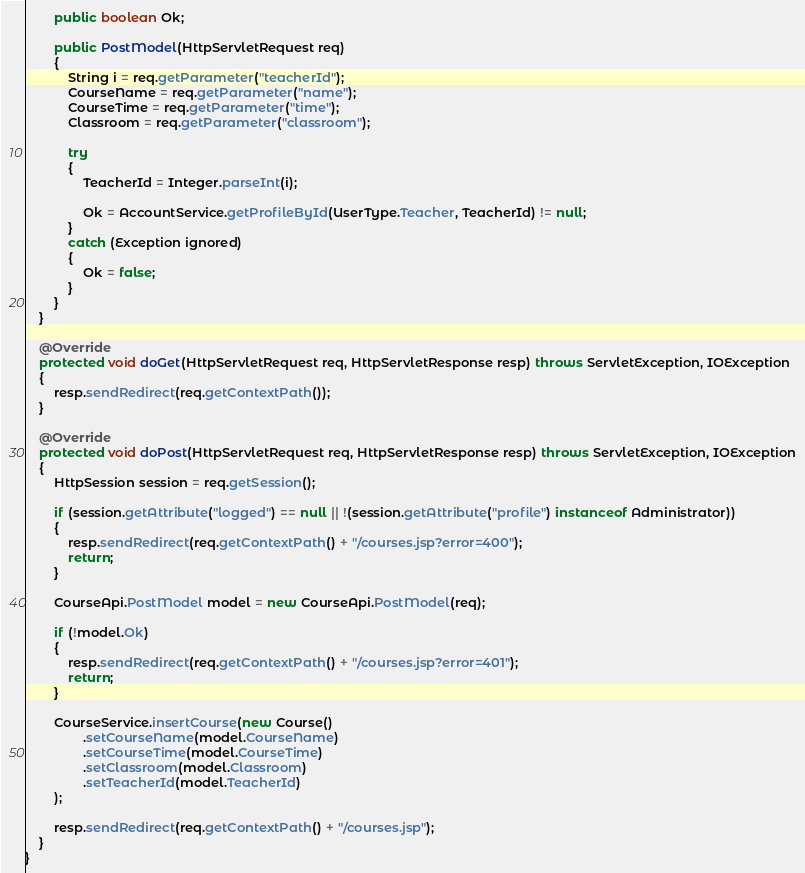Convert code to text. <code><loc_0><loc_0><loc_500><loc_500><_Java_>
        public boolean Ok;

        public PostModel(HttpServletRequest req)
        {
            String i = req.getParameter("teacherId");
            CourseName = req.getParameter("name");
            CourseTime = req.getParameter("time");
            Classroom = req.getParameter("classroom");

            try
            {
                TeacherId = Integer.parseInt(i);

                Ok = AccountService.getProfileById(UserType.Teacher, TeacherId) != null;
            }
            catch (Exception ignored)
            {
                Ok = false;
            }
        }
    }

    @Override
    protected void doGet(HttpServletRequest req, HttpServletResponse resp) throws ServletException, IOException
    {
        resp.sendRedirect(req.getContextPath());
    }

    @Override
    protected void doPost(HttpServletRequest req, HttpServletResponse resp) throws ServletException, IOException
    {
        HttpSession session = req.getSession();

        if (session.getAttribute("logged") == null || !(session.getAttribute("profile") instanceof Administrator))
        {
            resp.sendRedirect(req.getContextPath() + "/courses.jsp?error=400");
            return;
        }

        CourseApi.PostModel model = new CourseApi.PostModel(req);

        if (!model.Ok)
        {
            resp.sendRedirect(req.getContextPath() + "/courses.jsp?error=401");
            return;
        }

        CourseService.insertCourse(new Course()
                .setCourseName(model.CourseName)
                .setCourseTime(model.CourseTime)
                .setClassroom(model.Classroom)
                .setTeacherId(model.TeacherId)
        );

        resp.sendRedirect(req.getContextPath() + "/courses.jsp");
    }
}
</code> 